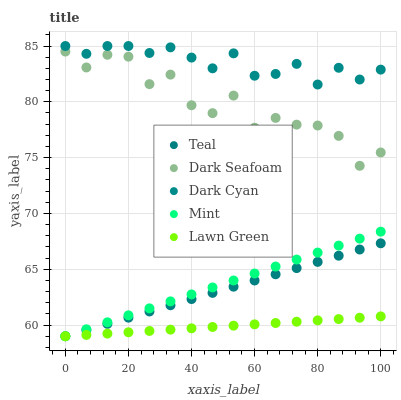Does Lawn Green have the minimum area under the curve?
Answer yes or no. Yes. Does Dark Cyan have the maximum area under the curve?
Answer yes or no. Yes. Does Dark Seafoam have the minimum area under the curve?
Answer yes or no. No. Does Dark Seafoam have the maximum area under the curve?
Answer yes or no. No. Is Lawn Green the smoothest?
Answer yes or no. Yes. Is Dark Seafoam the roughest?
Answer yes or no. Yes. Is Dark Seafoam the smoothest?
Answer yes or no. No. Is Lawn Green the roughest?
Answer yes or no. No. Does Lawn Green have the lowest value?
Answer yes or no. Yes. Does Dark Seafoam have the lowest value?
Answer yes or no. No. Does Dark Cyan have the highest value?
Answer yes or no. Yes. Does Dark Seafoam have the highest value?
Answer yes or no. No. Is Dark Seafoam less than Dark Cyan?
Answer yes or no. Yes. Is Dark Cyan greater than Teal?
Answer yes or no. Yes. Does Lawn Green intersect Teal?
Answer yes or no. Yes. Is Lawn Green less than Teal?
Answer yes or no. No. Is Lawn Green greater than Teal?
Answer yes or no. No. Does Dark Seafoam intersect Dark Cyan?
Answer yes or no. No. 